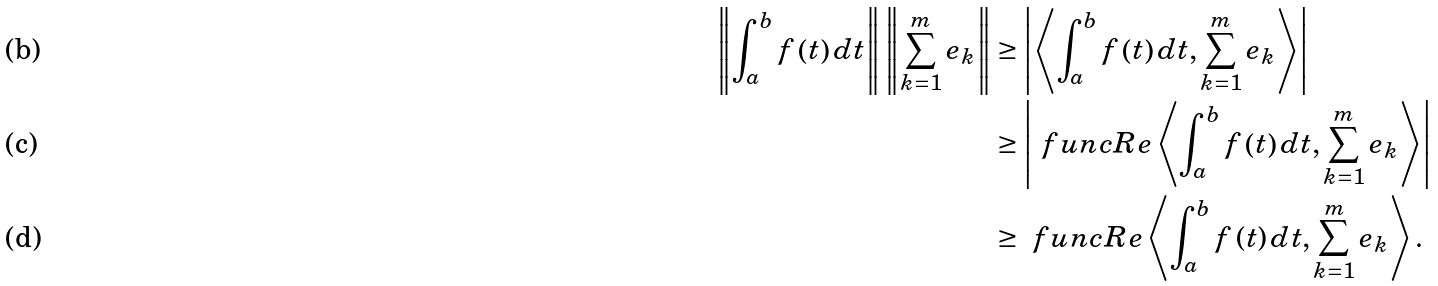Convert formula to latex. <formula><loc_0><loc_0><loc_500><loc_500>\left \| \int _ { a } ^ { b } f \left ( t \right ) d t \right \| \left \| \sum _ { k = 1 } ^ { m } e _ { k } \right \| & \geq \left | \left \langle \int _ { a } ^ { b } f \left ( t \right ) d t , \sum _ { k = 1 } ^ { m } e _ { k } \right \rangle \right | \\ & \geq \left | \ f u n c { R e } \left \langle \int _ { a } ^ { b } f \left ( t \right ) d t , \sum _ { k = 1 } ^ { m } e _ { k } \right \rangle \right | \\ & \geq \ f u n c { R e } \left \langle \int _ { a } ^ { b } f \left ( t \right ) d t , \sum _ { k = 1 } ^ { m } e _ { k } \right \rangle .</formula> 